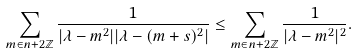Convert formula to latex. <formula><loc_0><loc_0><loc_500><loc_500>\sum _ { m \in n + 2 \mathbb { Z } } \frac { 1 } { | \lambda - m ^ { 2 } | | \lambda - ( m + s ) ^ { 2 } | } \leq \sum _ { m \in n + 2 \mathbb { Z } } \frac { 1 } { | \lambda - m ^ { 2 } | ^ { 2 } } .</formula> 